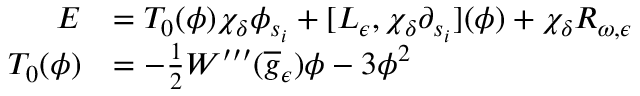Convert formula to latex. <formula><loc_0><loc_0><loc_500><loc_500>\begin{array} { r l } { E } & { = T _ { 0 } ( \phi ) \chi _ { \delta } \phi _ { s _ { i } } + [ L _ { \epsilon } , \chi _ { \delta } \partial _ { s _ { i } } ] ( \phi ) + \chi _ { \delta } R _ { \omega , \epsilon } } \\ { T _ { 0 } ( \phi ) } & { = - \frac { 1 } { 2 } W ^ { \prime \prime \prime } ( \overline { g } _ { \epsilon } ) \phi - 3 \phi ^ { 2 } } \end{array}</formula> 